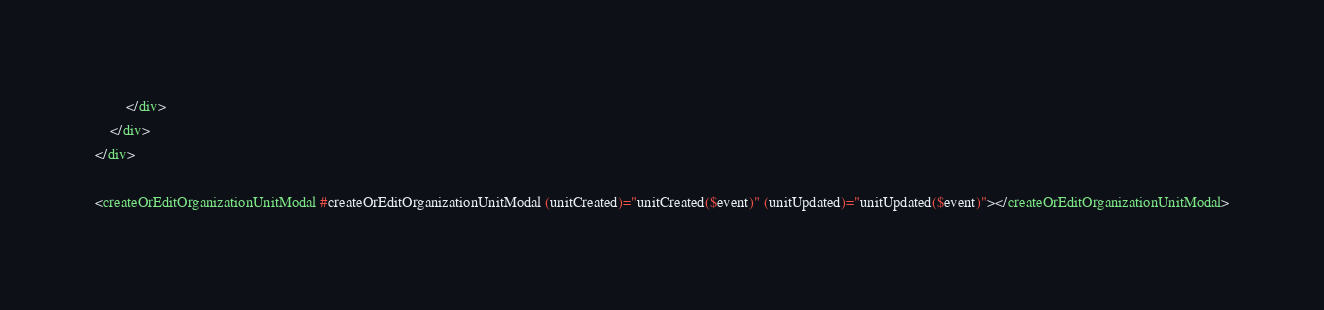Convert code to text. <code><loc_0><loc_0><loc_500><loc_500><_HTML_>        </div>
    </div>
</div>

<createOrEditOrganizationUnitModal #createOrEditOrganizationUnitModal (unitCreated)="unitCreated($event)" (unitUpdated)="unitUpdated($event)"></createOrEditOrganizationUnitModal>
</code> 